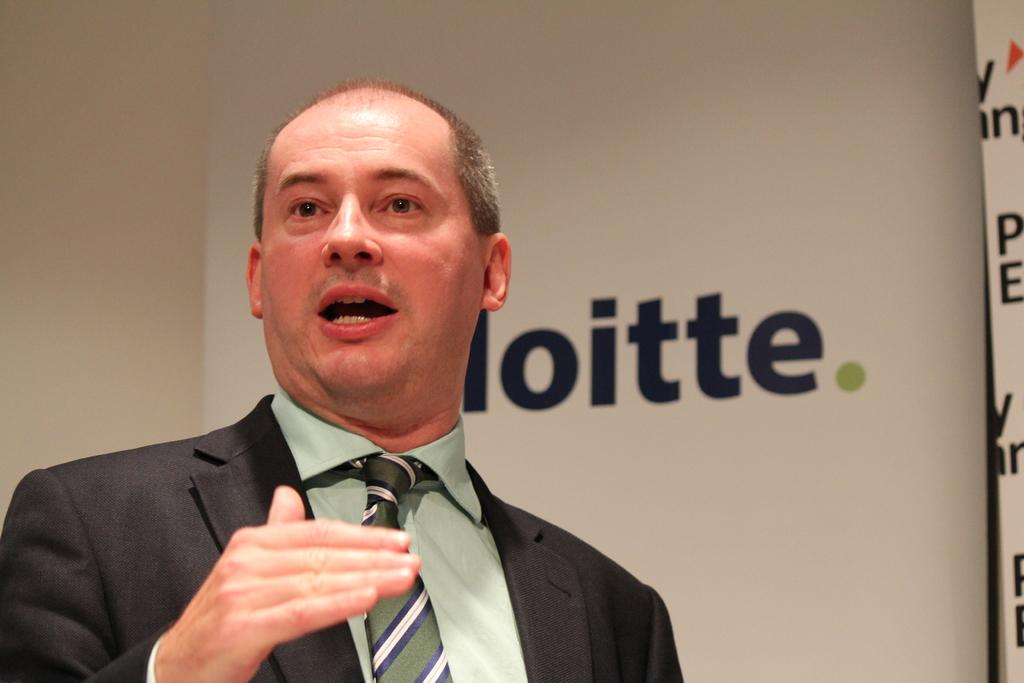What is the man in the image wearing? The man is wearing a suit, a tie, and a shirt in the image. What is the man doing in the image? The man is speaking in the image. Is there any text or symbol visible in the image? Yes, there is a logo on a banner in the image. Can you see the man's grandmother in the image? No, the man's grandmother is not present in the image. Is there any soap visible in the image? No, there is no soap present in the image. 